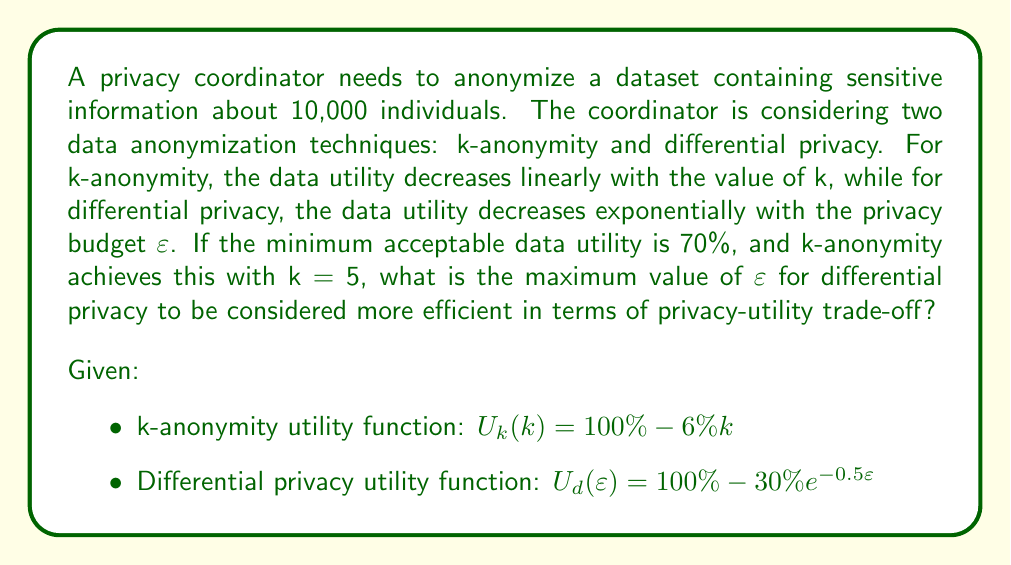Can you answer this question? To solve this problem, we need to follow these steps:

1. Calculate the utility for k-anonymity with k = 5:
   $U_k(5) = 100\% - 6\% \cdot 5 = 70\%$

2. Set up an equation for differential privacy to achieve the same utility:
   $U_d(\varepsilon) = 70\%$

3. Solve the equation for ε:
   $100\% - 30\%e^{-0.5\varepsilon} = 70\%$
   $30\%e^{-0.5\varepsilon} = 30\%$
   $e^{-0.5\varepsilon} = 1$
   $-0.5\varepsilon = \ln(1) = 0$
   $\varepsilon = 0$

4. Interpret the result:
   Since ε = 0 provides the same utility as k-anonymity with k = 5, any positive value of ε will result in higher utility for differential privacy.

5. Determine the maximum value of ε:
   To find the maximum value of ε that makes differential privacy more efficient, we need to consider the practical limitations. In most cases, ε values between 0.1 and 1 are considered reasonable for differential privacy. Therefore, the maximum value of ε should be just below 1.

6. Verify the result:
   Let's calculate the utility for differential privacy with ε = 0.99:
   $U_d(0.99) = 100\% - 30\%e^{-0.5 \cdot 0.99} \approx 85.9\%$

   This confirms that differential privacy with ε = 0.99 provides higher utility than k-anonymity with k = 5 (70%).
Answer: $\varepsilon = 0.99$ 